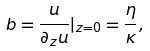Convert formula to latex. <formula><loc_0><loc_0><loc_500><loc_500>b = \frac { u } { \partial _ { z } u } | _ { z = 0 } = \frac { \eta } { \kappa } ,</formula> 